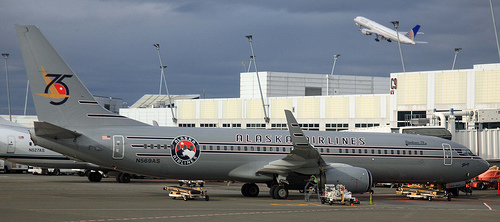Are there birds in this photograph? No, there are no birds present in this photograph; it depicts an airport scene with airplanes and ground support vehicles. 